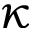<formula> <loc_0><loc_0><loc_500><loc_500>\kappa</formula> 